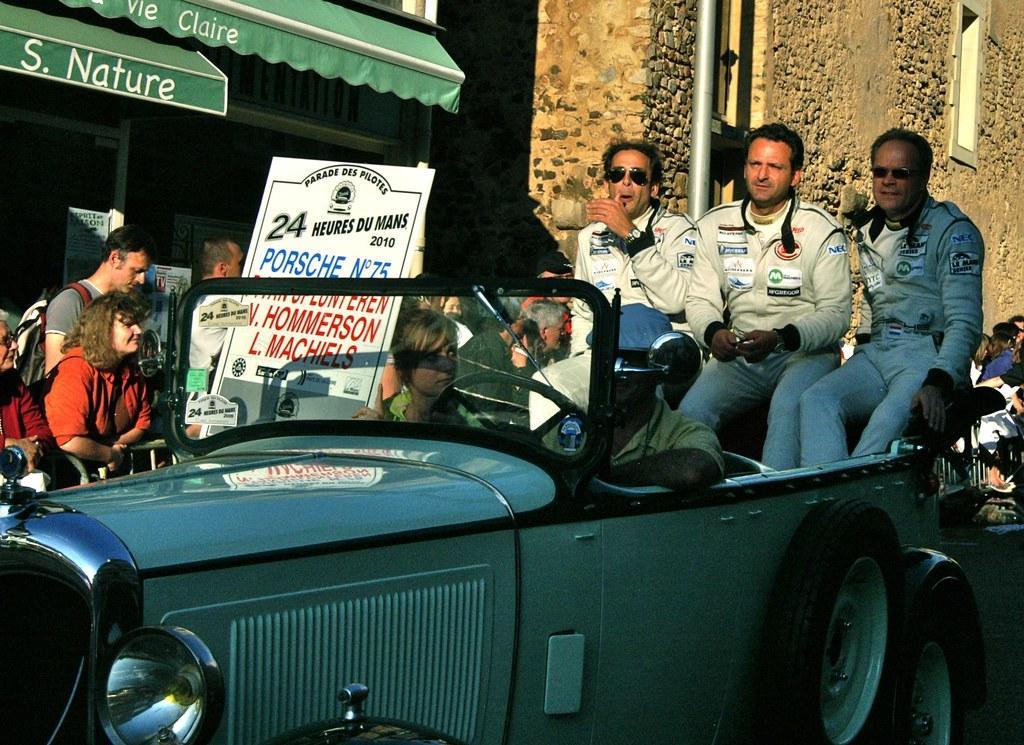Please provide a concise description of this image. In this picture we can see a old model car and person is riding the car he wore cap and woman is looking at him and in the background we can see group of people, banner, sun shade, wall, pole and a window for building. 